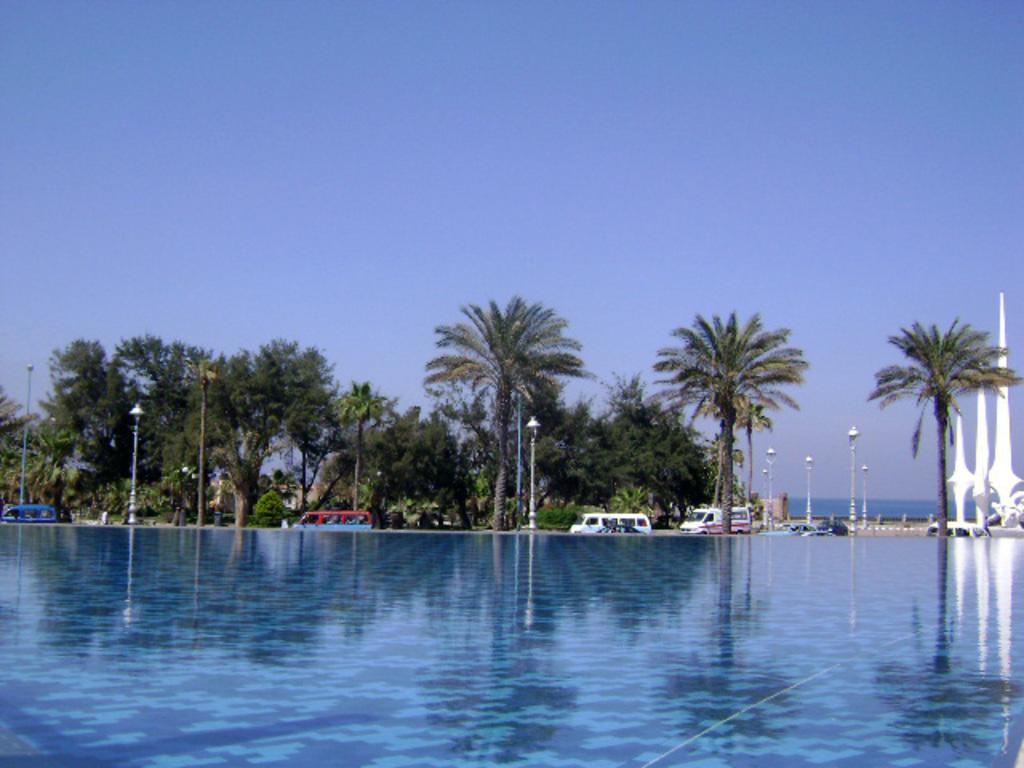In one or two sentences, can you explain what this image depicts? In this image, there is an outside view. There are some trees and vehicles in the middle of the image. In the background of the image, there is a sky. 